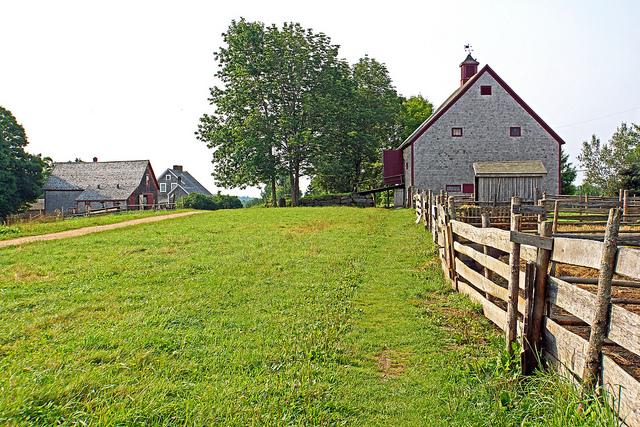What is the color of the houses chimney?
Quick response, please. Red. What material is the fence made of?
Short answer required. Wood. What is on top of the chimney?
Give a very brief answer. Weather vane. 